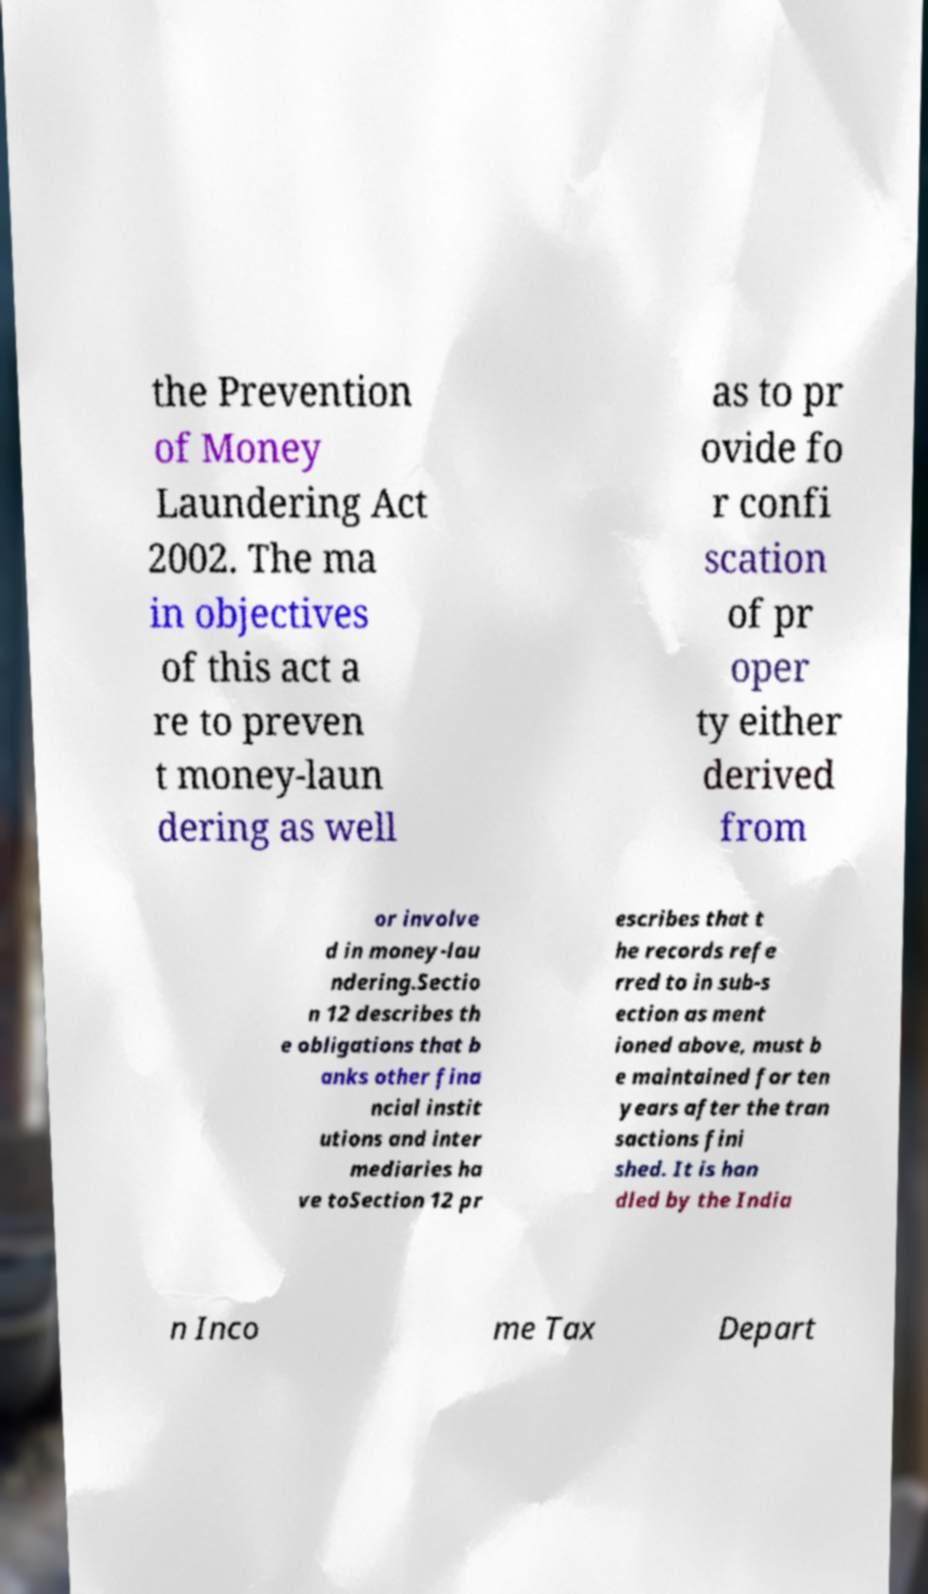Please identify and transcribe the text found in this image. the Prevention of Money Laundering Act 2002. The ma in objectives of this act a re to preven t money-laun dering as well as to pr ovide fo r confi scation of pr oper ty either derived from or involve d in money-lau ndering.Sectio n 12 describes th e obligations that b anks other fina ncial instit utions and inter mediaries ha ve toSection 12 pr escribes that t he records refe rred to in sub-s ection as ment ioned above, must b e maintained for ten years after the tran sactions fini shed. It is han dled by the India n Inco me Tax Depart 